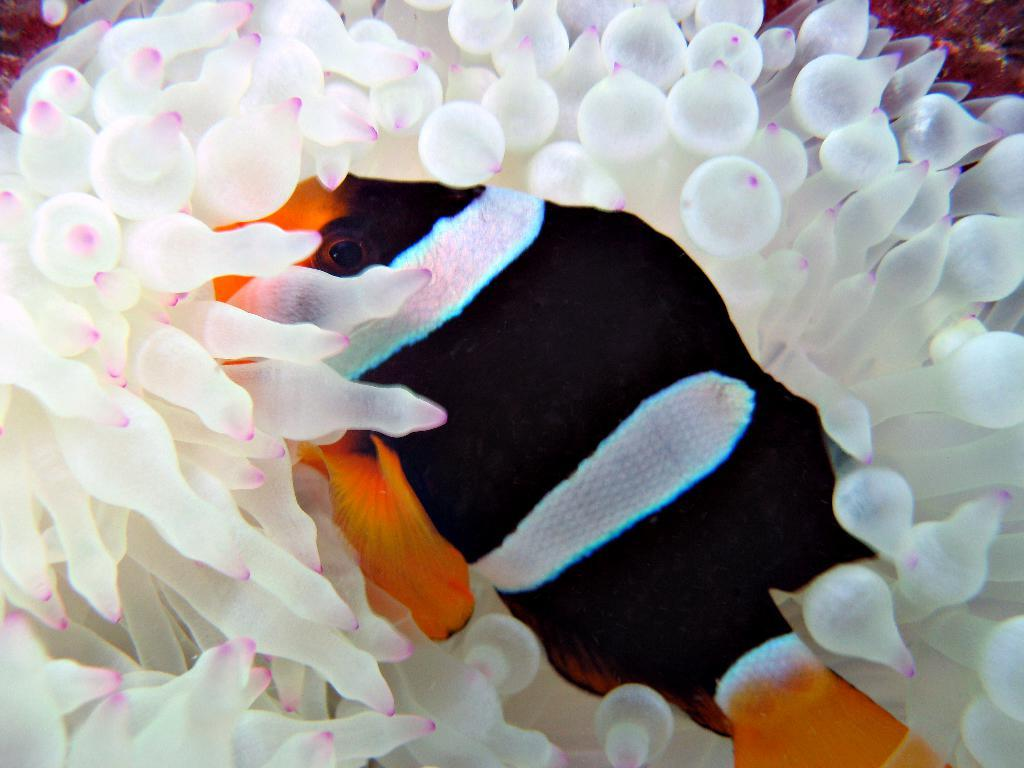What type of animal is present in the image? There is a fish in the image. What type of sink can be seen in the image? There is no sink present in the image; it only features a fish. How is the string used in the image? There is no string present in the image; it only features a fish. 